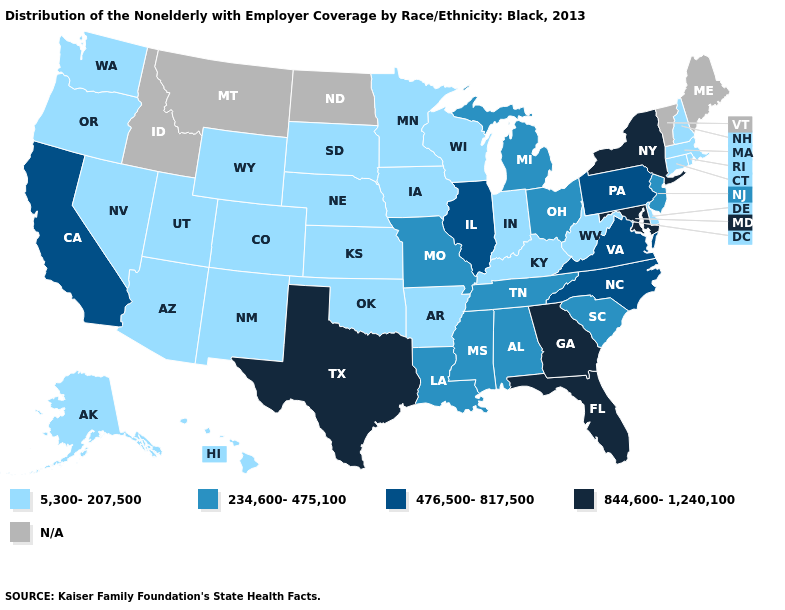Is the legend a continuous bar?
Write a very short answer. No. What is the value of Ohio?
Keep it brief. 234,600-475,100. Which states have the lowest value in the South?
Concise answer only. Arkansas, Delaware, Kentucky, Oklahoma, West Virginia. Does the first symbol in the legend represent the smallest category?
Be succinct. Yes. What is the value of Utah?
Be succinct. 5,300-207,500. What is the value of Utah?
Short answer required. 5,300-207,500. What is the value of Tennessee?
Keep it brief. 234,600-475,100. Name the states that have a value in the range 5,300-207,500?
Give a very brief answer. Alaska, Arizona, Arkansas, Colorado, Connecticut, Delaware, Hawaii, Indiana, Iowa, Kansas, Kentucky, Massachusetts, Minnesota, Nebraska, Nevada, New Hampshire, New Mexico, Oklahoma, Oregon, Rhode Island, South Dakota, Utah, Washington, West Virginia, Wisconsin, Wyoming. Does Pennsylvania have the lowest value in the Northeast?
Short answer required. No. What is the lowest value in the MidWest?
Write a very short answer. 5,300-207,500. Among the states that border Illinois , which have the highest value?
Give a very brief answer. Missouri. Name the states that have a value in the range 476,500-817,500?
Concise answer only. California, Illinois, North Carolina, Pennsylvania, Virginia. 